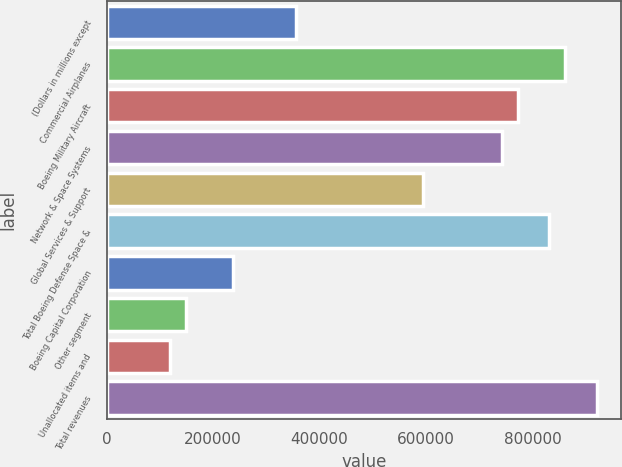<chart> <loc_0><loc_0><loc_500><loc_500><bar_chart><fcel>(Dollars in millions except<fcel>Commercial Airplanes<fcel>Boeing Military Aircraft<fcel>Network & Space Systems<fcel>Global Services & Support<fcel>Total Boeing Defense Space &<fcel>Boeing Capital Corporation<fcel>Other segment<fcel>Unallocated items and<fcel>Total revenues<nl><fcel>356356<fcel>861193<fcel>772104<fcel>742408<fcel>593926<fcel>831496<fcel>237571<fcel>148483<fcel>118786<fcel>920585<nl></chart> 